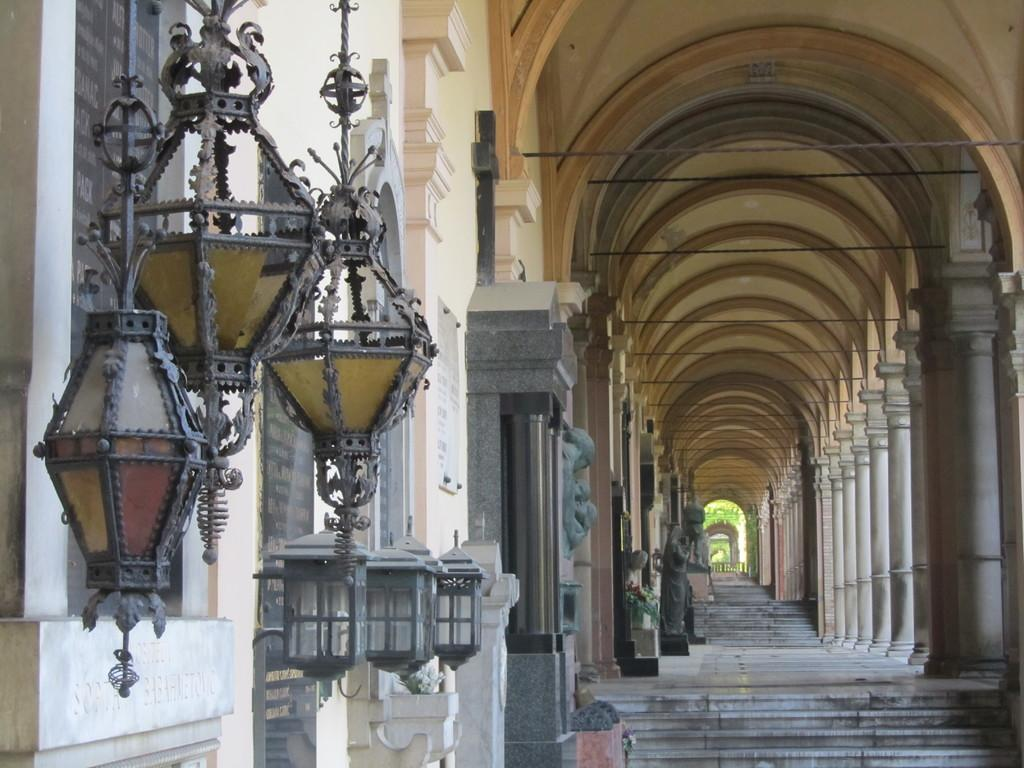What type of space is depicted in the image? The image consists of a corridor. Are there any architectural features in the front of the image? Yes, there are steps in the front of the image. What can be observed along the corridor? There are many pillars in the image. What type of lighting is present in the corridor? There are lamps hanged on the left wall of the corridor. How many babies are crawling on the floor in the image? There are no babies present in the image. What type of bat is hanging from the ceiling in the image? There is no bat present in the image; it is a corridor with pillars and lamps. 